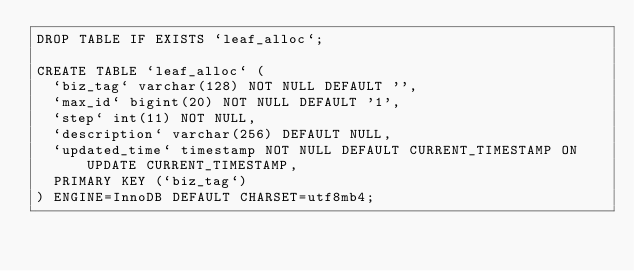Convert code to text. <code><loc_0><loc_0><loc_500><loc_500><_SQL_>DROP TABLE IF EXISTS `leaf_alloc`;

CREATE TABLE `leaf_alloc` (
  `biz_tag` varchar(128) NOT NULL DEFAULT '',
  `max_id` bigint(20) NOT NULL DEFAULT '1',
  `step` int(11) NOT NULL,
  `description` varchar(256) DEFAULT NULL,
  `updated_time` timestamp NOT NULL DEFAULT CURRENT_TIMESTAMP ON UPDATE CURRENT_TIMESTAMP,
  PRIMARY KEY (`biz_tag`)
) ENGINE=InnoDB DEFAULT CHARSET=utf8mb4;</code> 